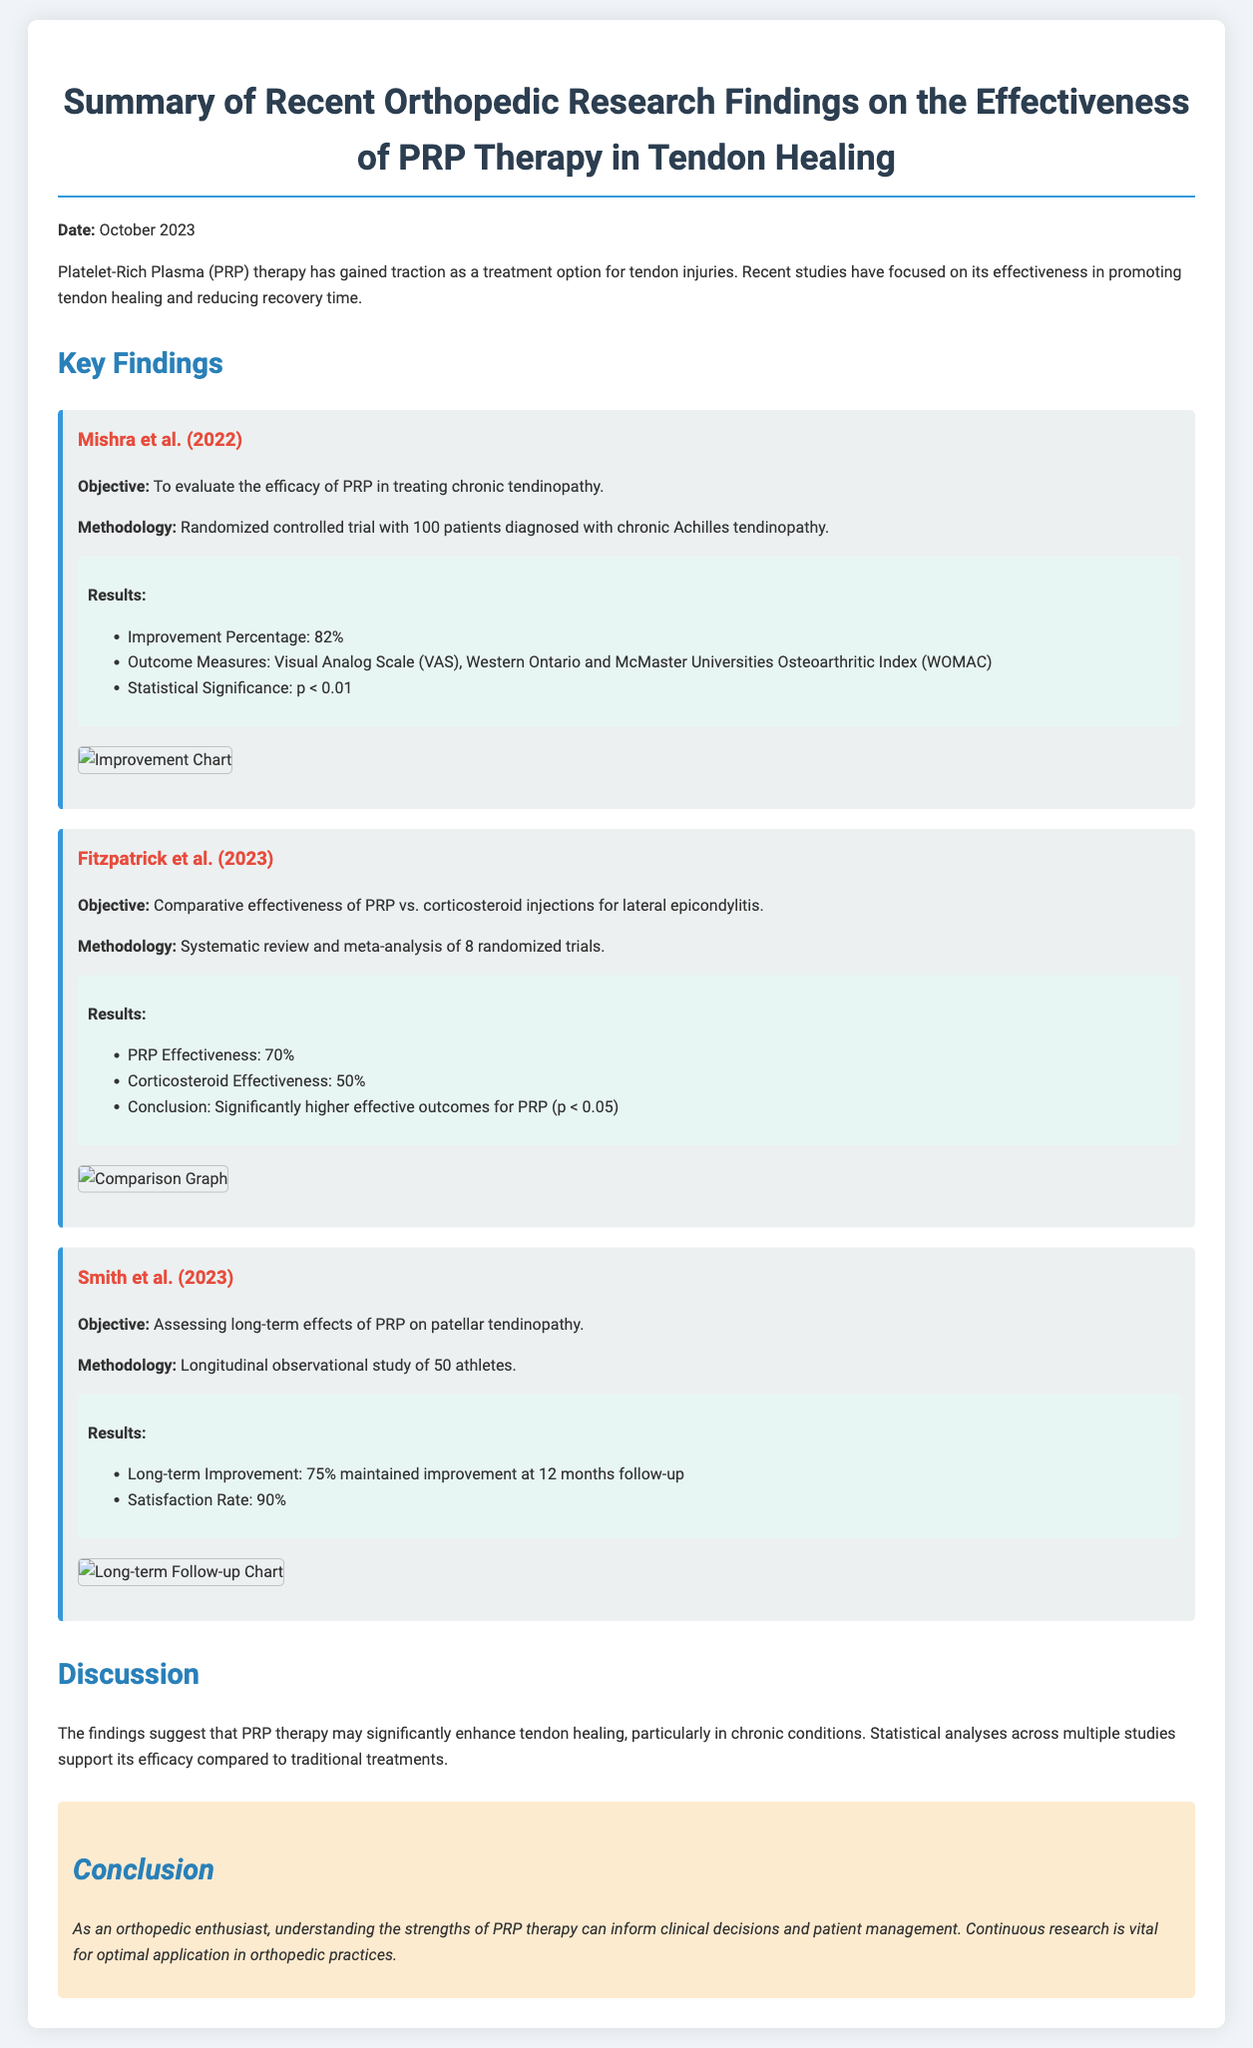What is the main objective of Mishra et al. (2022)? The main objective is to evaluate the efficacy of PRP in treating chronic tendinopathy.
Answer: To evaluate the efficacy of PRP in treating chronic tendinopathy What was the improvement percentage reported by Mishra et al. (2022)? The improvement percentage reported is 82%.
Answer: 82% What were the two outcome measures used in Mishra et al. (2022)? The outcome measures were Visual Analog Scale (VAS) and Western Ontario and McMaster Universities Osteoarthritic Index (WOMAC).
Answer: Visual Analog Scale (VAS), Western Ontario and McMaster Universities Osteoarthritic Index (WOMAC) What is the statistical significance reported by Fitzpatrick et al. (2023) for PRP effectiveness? The statistical significance for PRP effectiveness is p < 0.05.
Answer: p < 0.05 How many patients were involved in the study by Smith et al. (2023)? The study involved 50 athletes.
Answer: 50 athletes What percentage of long-term improvement was maintained at 12 months according to Smith et al. (2023)? The long-term improvement maintained at 12 months was 75%.
Answer: 75% What conclusion is drawn about PRP therapy in the document? The conclusion suggests that PRP therapy may significantly enhance tendon healing.
Answer: PRP therapy may significantly enhance tendon healing Which study compared the effectiveness of PRP and corticosteroid injections? The study that compared the effectiveness is Fitzpatrick et al. (2023).
Answer: Fitzpatrick et al. (2023) What year was the summary of findings published? The summary of findings was published in October 2023.
Answer: October 2023 